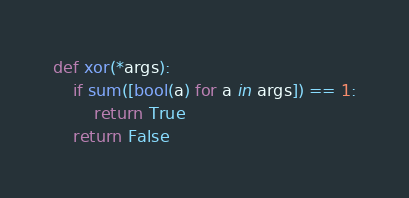<code> <loc_0><loc_0><loc_500><loc_500><_Python_>def xor(*args):
    if sum([bool(a) for a in args]) == 1:
        return True
    return False
</code> 